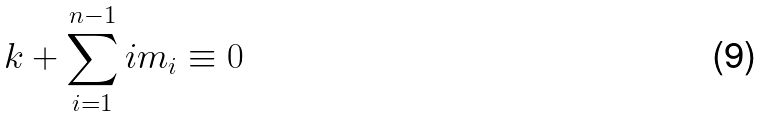Convert formula to latex. <formula><loc_0><loc_0><loc_500><loc_500>k + \sum _ { i = 1 } ^ { n - 1 } i m _ { i } \equiv 0</formula> 